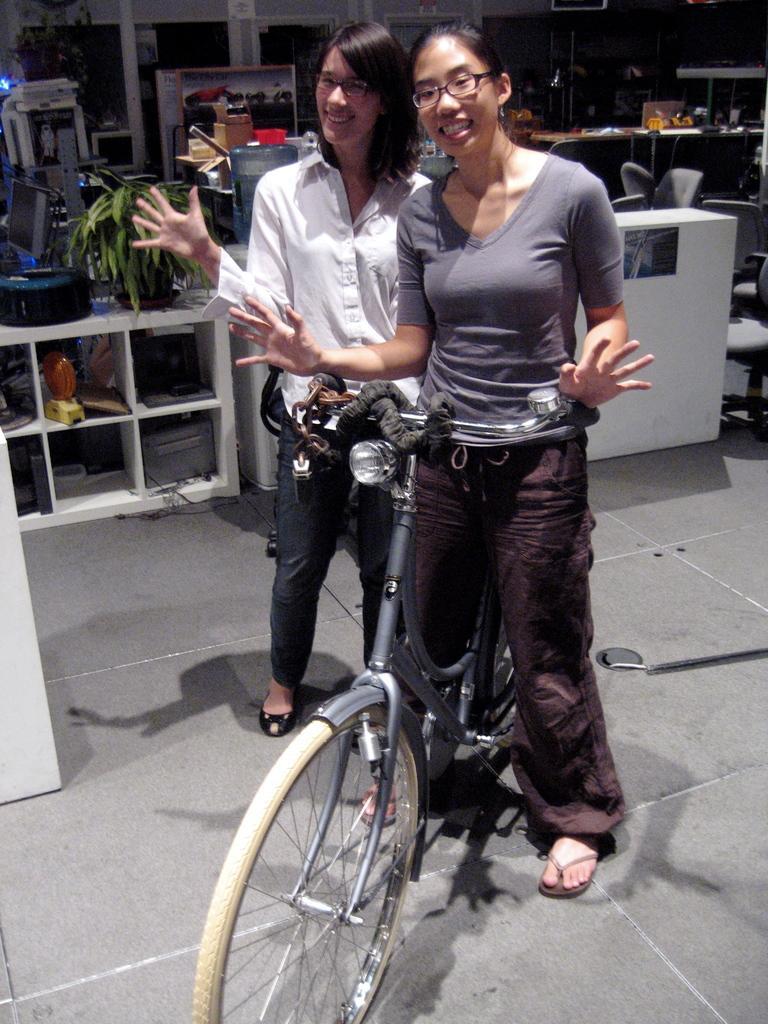Please provide a concise description of this image. In this image we can see two people standing on the ground. We can also see a bicycle. On the backside we can see some objects placed in the shelves, a plant in a pot, a laptop and some objects placed on the tables. We can also see some chairs, devices and some frames. 